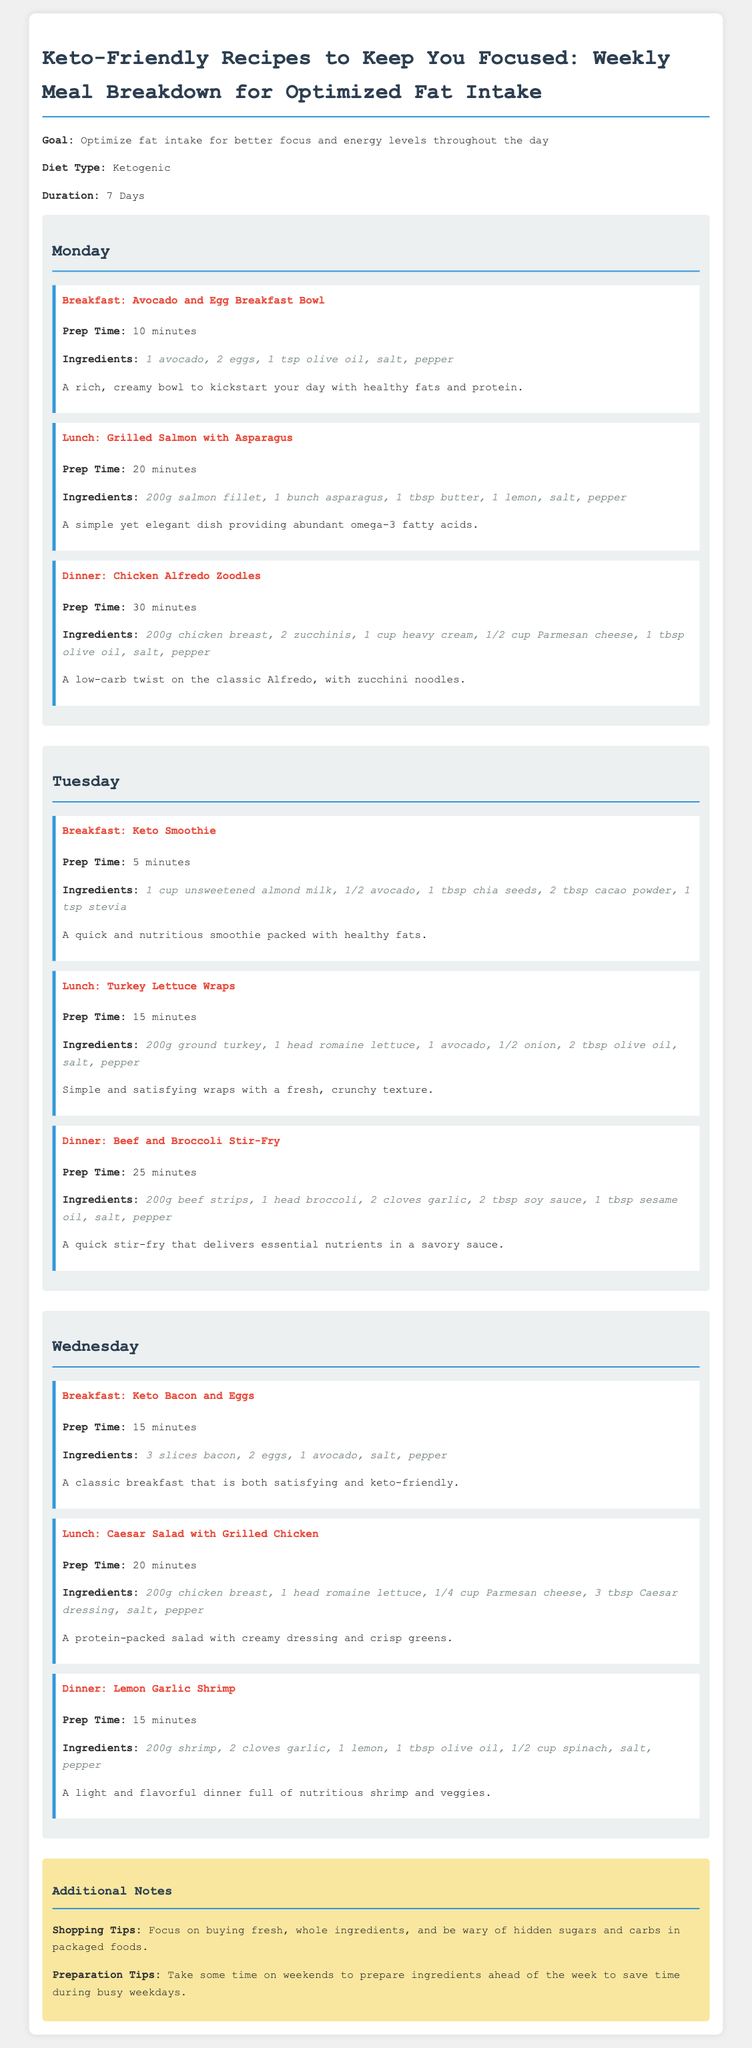What is the goal of the meal plan? The goal is to optimize fat intake for better focus and energy levels throughout the day.
Answer: Optimize fat intake for better focus and energy levels throughout the day How long is the meal plan designed to last? The duration of the meal plan is specified in the document as 7 days.
Answer: 7 Days What is the prep time for the Keto Smoothie? The prep time is a specific detail provided for the meal, which is 5 minutes.
Answer: 5 minutes Which day features Chicken Alfredo Zoodles for dinner? By checking the listed meals under each day, Chicken Alfredo Zoodles is found under Monday's dinner.
Answer: Monday What ingredients are needed for the Grilled Salmon with Asparagus lunch? The ingredients for this meal include salmon, asparagus, butter, lemon, salt, and pepper, as stated.
Answer: 200g salmon fillet, 1 bunch asparagus, 1 tbsp butter, 1 lemon, salt, pepper How many slices of bacon are in the Keto Bacon and Eggs breakfast? The specific number of bacon slices in this meal is mentioned, which is 3.
Answer: 3 slices What preparation tips does the document provide? The preparation tips include preparing ingredients ahead of the week, which aids in saving time during busy weekdays.
Answer: Prepare ingredients ahead of the week What type of diet is this meal plan categorized under? The diet type is highlighted in the document, classifying it as a ketogenic diet.
Answer: Ketogenic 